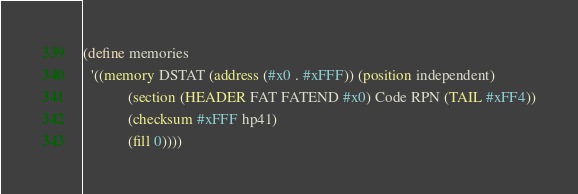<code> <loc_0><loc_0><loc_500><loc_500><_Scheme_>(define memories
  '((memory DSTAT (address (#x0 . #xFFF)) (position independent)
            (section (HEADER FAT FATEND #x0) Code RPN (TAIL #xFF4))
            (checksum #xFFF hp41)
            (fill 0))))
</code> 